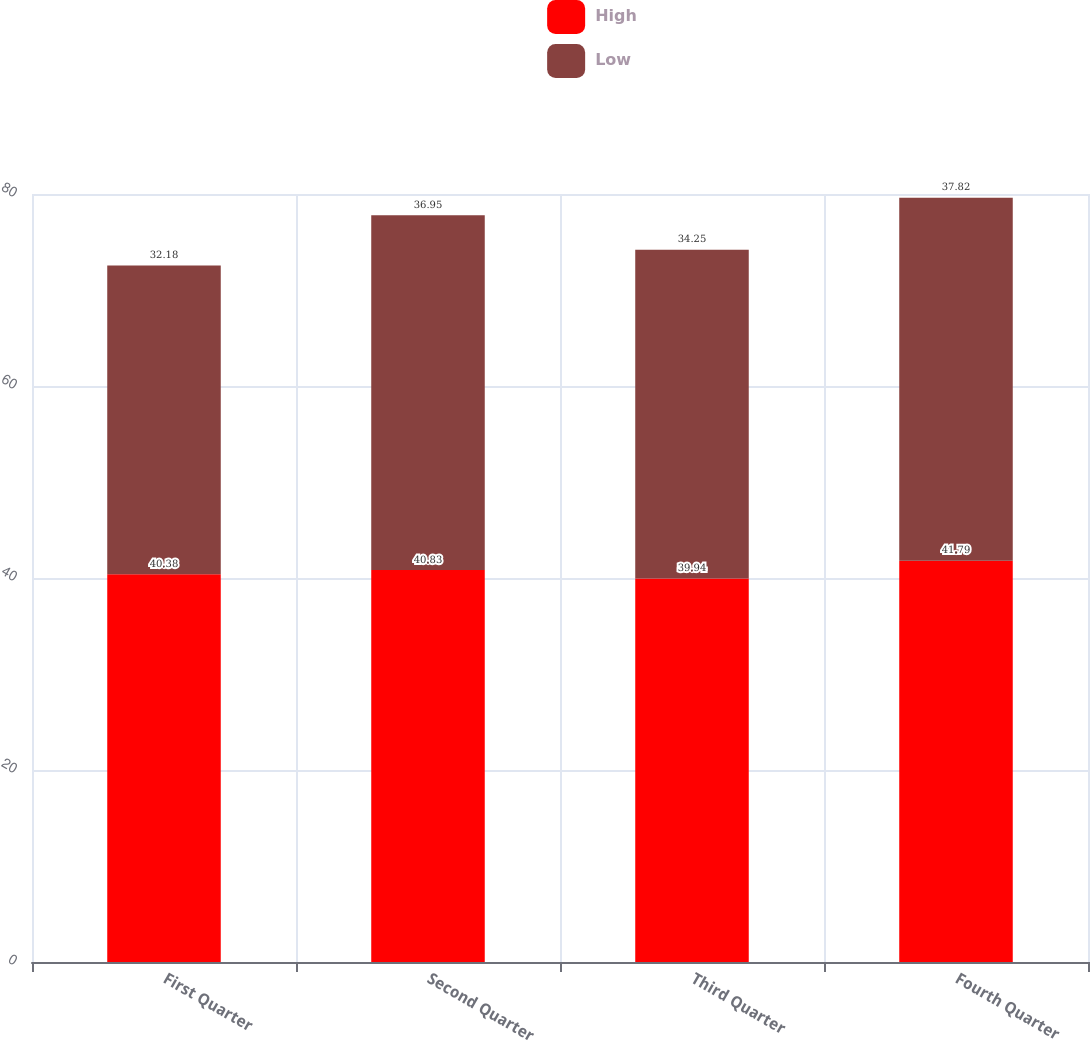Convert chart to OTSL. <chart><loc_0><loc_0><loc_500><loc_500><stacked_bar_chart><ecel><fcel>First Quarter<fcel>Second Quarter<fcel>Third Quarter<fcel>Fourth Quarter<nl><fcel>High<fcel>40.38<fcel>40.83<fcel>39.94<fcel>41.79<nl><fcel>Low<fcel>32.18<fcel>36.95<fcel>34.25<fcel>37.82<nl></chart> 